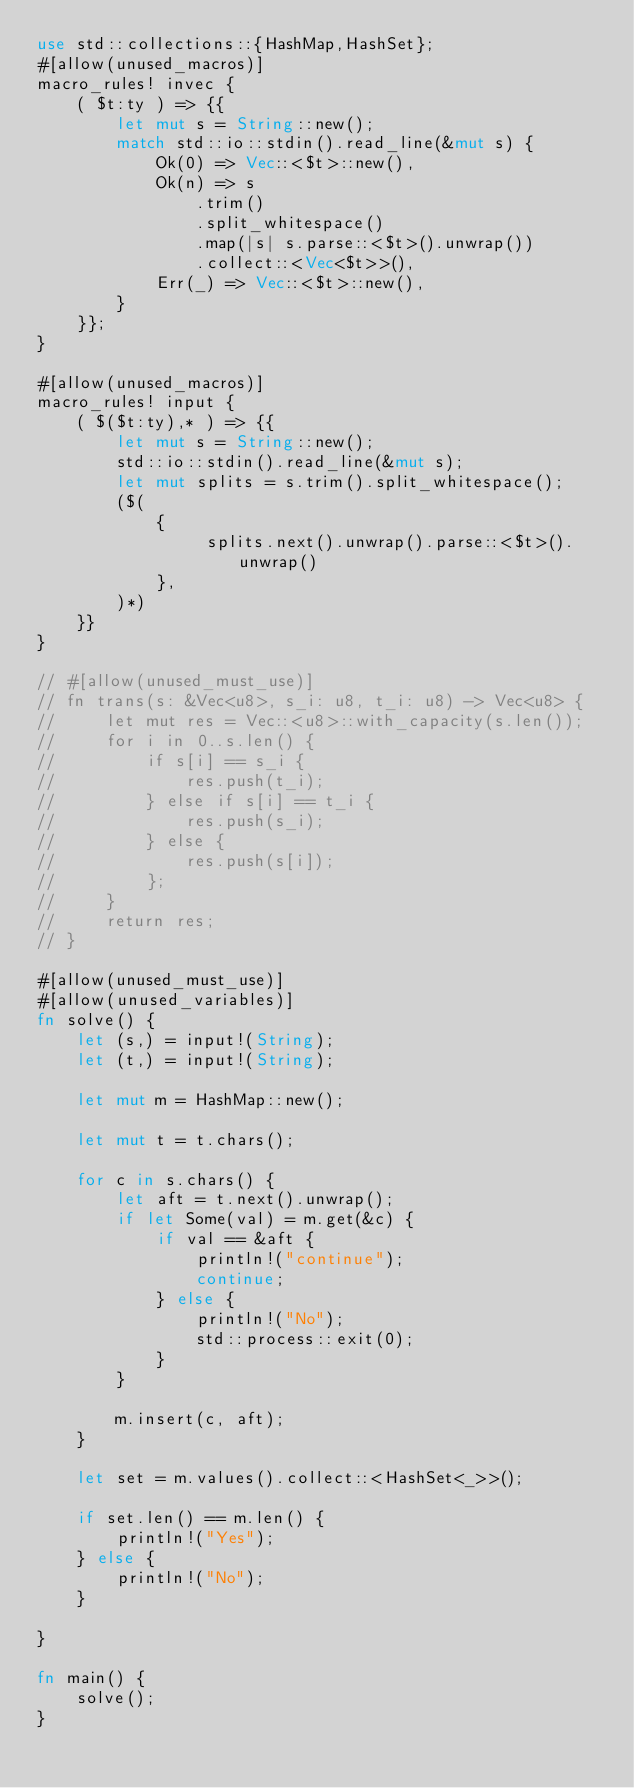Convert code to text. <code><loc_0><loc_0><loc_500><loc_500><_Rust_>use std::collections::{HashMap,HashSet};
#[allow(unused_macros)]
macro_rules! invec {
    ( $t:ty ) => {{
        let mut s = String::new();
        match std::io::stdin().read_line(&mut s) {
            Ok(0) => Vec::<$t>::new(),
            Ok(n) => s
                .trim()
                .split_whitespace()
                .map(|s| s.parse::<$t>().unwrap())
                .collect::<Vec<$t>>(),
            Err(_) => Vec::<$t>::new(),
        }
    }};
}

#[allow(unused_macros)]
macro_rules! input {
    ( $($t:ty),* ) => {{
        let mut s = String::new();
        std::io::stdin().read_line(&mut s);
        let mut splits = s.trim().split_whitespace();
        ($(
            {
                 splits.next().unwrap().parse::<$t>().unwrap()
            },
        )*)
    }}
}

// #[allow(unused_must_use)]
// fn trans(s: &Vec<u8>, s_i: u8, t_i: u8) -> Vec<u8> {
//     let mut res = Vec::<u8>::with_capacity(s.len());
//     for i in 0..s.len() {
//         if s[i] == s_i {
//             res.push(t_i);
//         } else if s[i] == t_i {
//             res.push(s_i);
//         } else {
//             res.push(s[i]);
//         };
//     }
//     return res;
// }

#[allow(unused_must_use)]
#[allow(unused_variables)]
fn solve() {
    let (s,) = input!(String);
    let (t,) = input!(String);

    let mut m = HashMap::new();

    let mut t = t.chars();

    for c in s.chars() {
        let aft = t.next().unwrap();
        if let Some(val) = m.get(&c) {
            if val == &aft {
                println!("continue");
                continue;
            } else {
                println!("No");
                std::process::exit(0);
            }
        }

        m.insert(c, aft);
    }

    let set = m.values().collect::<HashSet<_>>();

    if set.len() == m.len() {
        println!("Yes");
    } else {
        println!("No");
    }

}

fn main() {
    solve();
}
</code> 